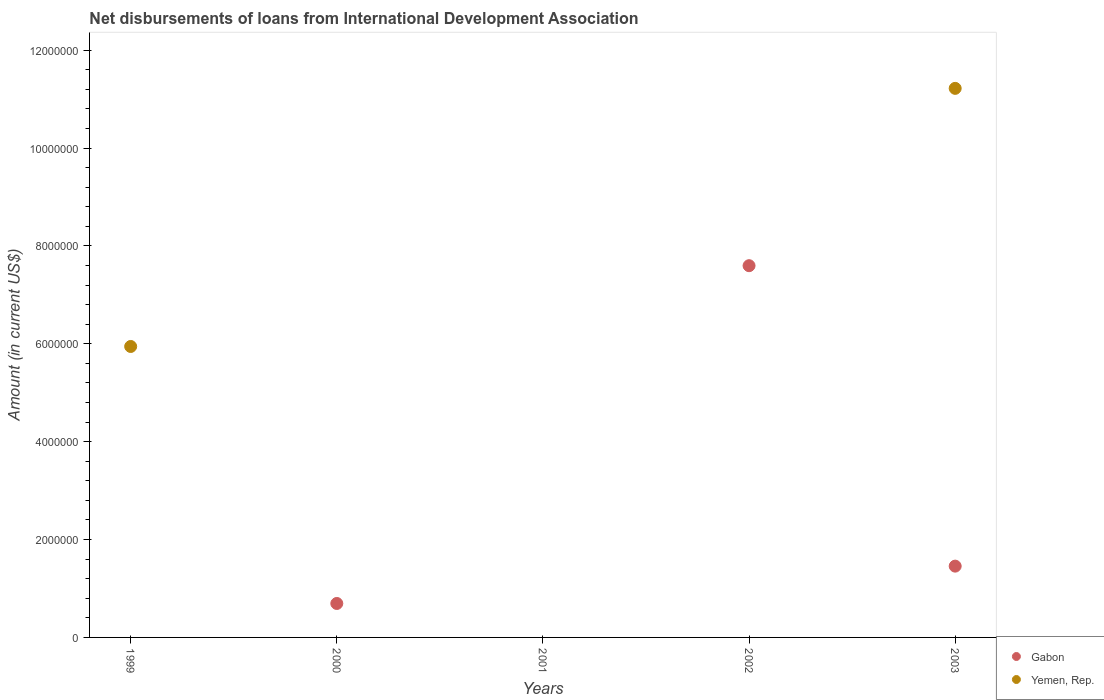How many different coloured dotlines are there?
Give a very brief answer. 2. Is the number of dotlines equal to the number of legend labels?
Offer a very short reply. No. What is the amount of loans disbursed in Yemen, Rep. in 1999?
Your answer should be very brief. 5.95e+06. Across all years, what is the maximum amount of loans disbursed in Gabon?
Your response must be concise. 7.60e+06. Across all years, what is the minimum amount of loans disbursed in Yemen, Rep.?
Make the answer very short. 0. In which year was the amount of loans disbursed in Yemen, Rep. maximum?
Provide a short and direct response. 2003. What is the total amount of loans disbursed in Yemen, Rep. in the graph?
Provide a succinct answer. 1.72e+07. What is the difference between the amount of loans disbursed in Gabon in 2000 and that in 2002?
Give a very brief answer. -6.90e+06. What is the difference between the amount of loans disbursed in Gabon in 1999 and the amount of loans disbursed in Yemen, Rep. in 2000?
Offer a very short reply. 0. What is the average amount of loans disbursed in Gabon per year?
Your answer should be very brief. 1.95e+06. In the year 2003, what is the difference between the amount of loans disbursed in Gabon and amount of loans disbursed in Yemen, Rep.?
Give a very brief answer. -9.76e+06. In how many years, is the amount of loans disbursed in Gabon greater than 5200000 US$?
Give a very brief answer. 1. What is the ratio of the amount of loans disbursed in Gabon in 2000 to that in 2003?
Offer a very short reply. 0.48. What is the difference between the highest and the second highest amount of loans disbursed in Gabon?
Provide a short and direct response. 6.14e+06. What is the difference between the highest and the lowest amount of loans disbursed in Gabon?
Offer a terse response. 7.60e+06. In how many years, is the amount of loans disbursed in Yemen, Rep. greater than the average amount of loans disbursed in Yemen, Rep. taken over all years?
Ensure brevity in your answer.  2. Does the amount of loans disbursed in Gabon monotonically increase over the years?
Offer a terse response. No. Is the amount of loans disbursed in Yemen, Rep. strictly less than the amount of loans disbursed in Gabon over the years?
Your answer should be very brief. No. How many dotlines are there?
Give a very brief answer. 2. What is the difference between two consecutive major ticks on the Y-axis?
Your answer should be very brief. 2.00e+06. Does the graph contain any zero values?
Make the answer very short. Yes. Does the graph contain grids?
Your response must be concise. No. How many legend labels are there?
Make the answer very short. 2. What is the title of the graph?
Offer a terse response. Net disbursements of loans from International Development Association. Does "Antigua and Barbuda" appear as one of the legend labels in the graph?
Your response must be concise. No. What is the label or title of the X-axis?
Ensure brevity in your answer.  Years. What is the label or title of the Y-axis?
Offer a terse response. Amount (in current US$). What is the Amount (in current US$) in Gabon in 1999?
Ensure brevity in your answer.  0. What is the Amount (in current US$) in Yemen, Rep. in 1999?
Make the answer very short. 5.95e+06. What is the Amount (in current US$) of Gabon in 2000?
Provide a short and direct response. 6.94e+05. What is the Amount (in current US$) of Yemen, Rep. in 2000?
Keep it short and to the point. 0. What is the Amount (in current US$) of Yemen, Rep. in 2001?
Provide a succinct answer. 0. What is the Amount (in current US$) in Gabon in 2002?
Offer a terse response. 7.60e+06. What is the Amount (in current US$) of Yemen, Rep. in 2002?
Your answer should be compact. 0. What is the Amount (in current US$) in Gabon in 2003?
Provide a short and direct response. 1.46e+06. What is the Amount (in current US$) in Yemen, Rep. in 2003?
Your response must be concise. 1.12e+07. Across all years, what is the maximum Amount (in current US$) of Gabon?
Your answer should be compact. 7.60e+06. Across all years, what is the maximum Amount (in current US$) of Yemen, Rep.?
Offer a very short reply. 1.12e+07. Across all years, what is the minimum Amount (in current US$) of Gabon?
Give a very brief answer. 0. What is the total Amount (in current US$) of Gabon in the graph?
Offer a terse response. 9.75e+06. What is the total Amount (in current US$) of Yemen, Rep. in the graph?
Offer a very short reply. 1.72e+07. What is the difference between the Amount (in current US$) of Yemen, Rep. in 1999 and that in 2003?
Your answer should be compact. -5.28e+06. What is the difference between the Amount (in current US$) of Gabon in 2000 and that in 2002?
Ensure brevity in your answer.  -6.90e+06. What is the difference between the Amount (in current US$) in Gabon in 2000 and that in 2003?
Provide a succinct answer. -7.63e+05. What is the difference between the Amount (in current US$) of Gabon in 2002 and that in 2003?
Offer a very short reply. 6.14e+06. What is the difference between the Amount (in current US$) of Gabon in 2000 and the Amount (in current US$) of Yemen, Rep. in 2003?
Make the answer very short. -1.05e+07. What is the difference between the Amount (in current US$) in Gabon in 2002 and the Amount (in current US$) in Yemen, Rep. in 2003?
Provide a succinct answer. -3.62e+06. What is the average Amount (in current US$) of Gabon per year?
Your answer should be compact. 1.95e+06. What is the average Amount (in current US$) in Yemen, Rep. per year?
Offer a terse response. 3.43e+06. In the year 2003, what is the difference between the Amount (in current US$) in Gabon and Amount (in current US$) in Yemen, Rep.?
Ensure brevity in your answer.  -9.76e+06. What is the ratio of the Amount (in current US$) in Yemen, Rep. in 1999 to that in 2003?
Your response must be concise. 0.53. What is the ratio of the Amount (in current US$) of Gabon in 2000 to that in 2002?
Offer a terse response. 0.09. What is the ratio of the Amount (in current US$) in Gabon in 2000 to that in 2003?
Make the answer very short. 0.48. What is the ratio of the Amount (in current US$) of Gabon in 2002 to that in 2003?
Keep it short and to the point. 5.21. What is the difference between the highest and the second highest Amount (in current US$) of Gabon?
Ensure brevity in your answer.  6.14e+06. What is the difference between the highest and the lowest Amount (in current US$) of Gabon?
Provide a succinct answer. 7.60e+06. What is the difference between the highest and the lowest Amount (in current US$) in Yemen, Rep.?
Give a very brief answer. 1.12e+07. 